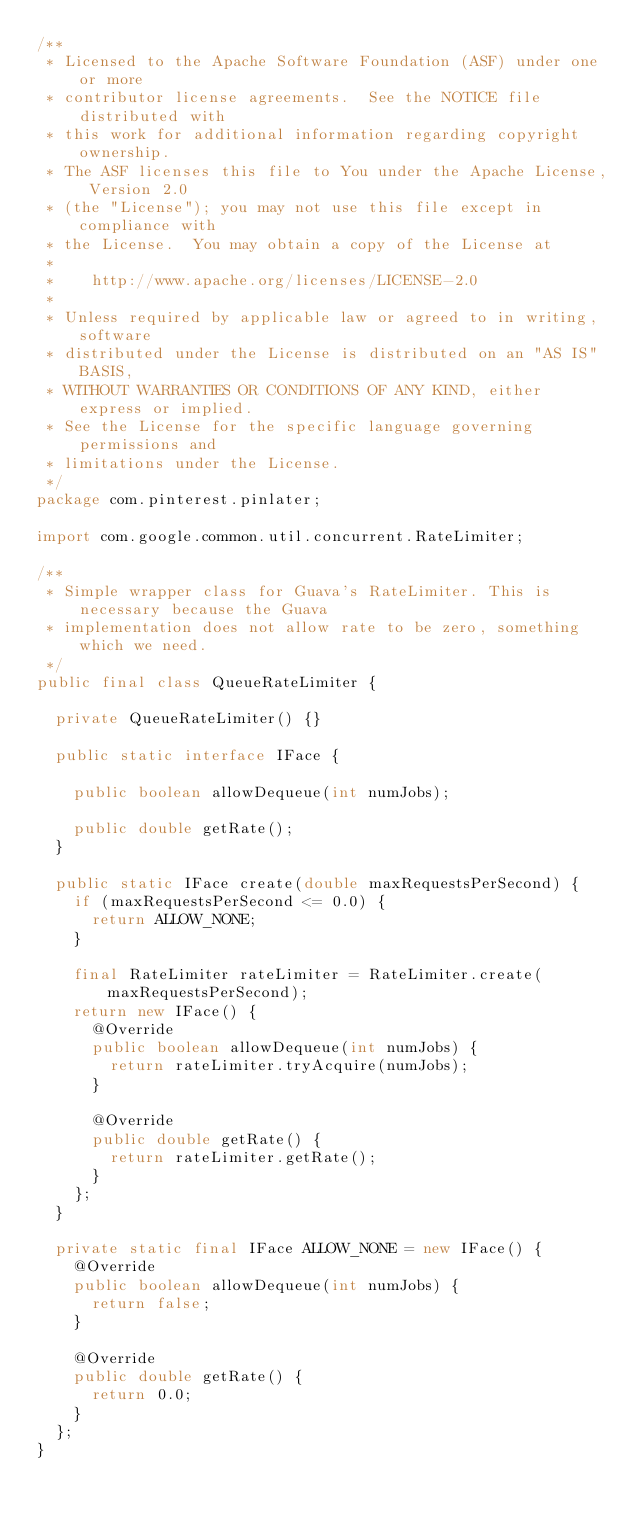Convert code to text. <code><loc_0><loc_0><loc_500><loc_500><_Java_>/**
 * Licensed to the Apache Software Foundation (ASF) under one or more
 * contributor license agreements.  See the NOTICE file distributed with
 * this work for additional information regarding copyright ownership.
 * The ASF licenses this file to You under the Apache License, Version 2.0
 * (the "License"); you may not use this file except in compliance with
 * the License.  You may obtain a copy of the License at
 *
 *    http://www.apache.org/licenses/LICENSE-2.0
 *
 * Unless required by applicable law or agreed to in writing, software
 * distributed under the License is distributed on an "AS IS" BASIS,
 * WITHOUT WARRANTIES OR CONDITIONS OF ANY KIND, either express or implied.
 * See the License for the specific language governing permissions and
 * limitations under the License.
 */
package com.pinterest.pinlater;

import com.google.common.util.concurrent.RateLimiter;

/**
 * Simple wrapper class for Guava's RateLimiter. This is necessary because the Guava
 * implementation does not allow rate to be zero, something which we need.
 */
public final class QueueRateLimiter {

  private QueueRateLimiter() {}

  public static interface IFace {

    public boolean allowDequeue(int numJobs);

    public double getRate();
  }

  public static IFace create(double maxRequestsPerSecond) {
    if (maxRequestsPerSecond <= 0.0) {
      return ALLOW_NONE;
    }

    final RateLimiter rateLimiter = RateLimiter.create(maxRequestsPerSecond);
    return new IFace() {
      @Override
      public boolean allowDequeue(int numJobs) {
        return rateLimiter.tryAcquire(numJobs);
      }

      @Override
      public double getRate() {
        return rateLimiter.getRate();
      }
    };
  }

  private static final IFace ALLOW_NONE = new IFace() {
    @Override
    public boolean allowDequeue(int numJobs) {
      return false;
    }

    @Override
    public double getRate() {
      return 0.0;
    }
  };
}
</code> 